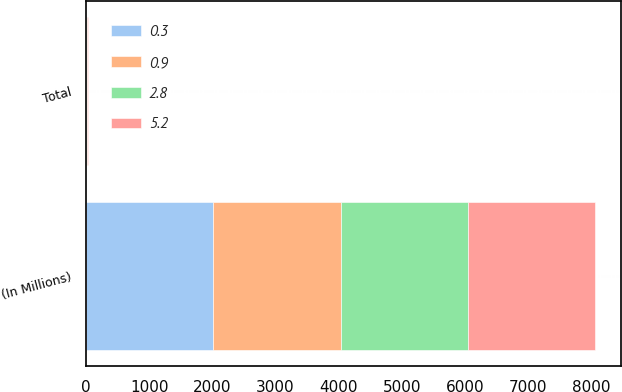Convert chart. <chart><loc_0><loc_0><loc_500><loc_500><stacked_bar_chart><ecel><fcel>(In Millions)<fcel>Total<nl><fcel>5.2<fcel>2017<fcel>24.2<nl><fcel>0.3<fcel>2016<fcel>0.9<nl><fcel>2.8<fcel>2015<fcel>9.9<nl><fcel>0.9<fcel>2017<fcel>0.3<nl></chart> 